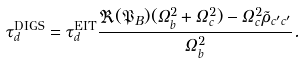Convert formula to latex. <formula><loc_0><loc_0><loc_500><loc_500>\tau _ { d } ^ { \text {DIGS} } = \tau _ { d } ^ { \text {EIT} } \frac { \Re ( \mathfrak { P } _ { B } ) ( \Omega _ { b } ^ { 2 } + \Omega _ { c } ^ { 2 } ) - \Omega _ { c } ^ { 2 } \tilde { \rho } _ { c ^ { \prime } c ^ { \prime } } } { \Omega _ { b } ^ { 2 } } .</formula> 